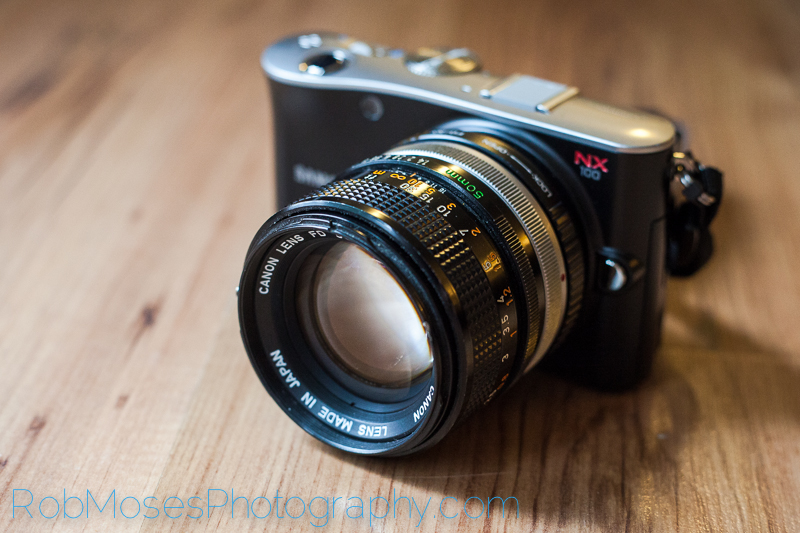What does the lettering on the lens indicate, and how can it help in photography? The lettering on the Canon FD lens provides crucial information about its specifications and functionality. For example, it may indicate the focal length (e.g., 50mm), maximum aperture (e.g., f/1.4), and other details such as lens series and filter size. This information helps photographers understand the lens's capabilities: the focal length determines the field of view, while the maximum aperture affects depth of field and low-light performance. Knowing these specifications allows photographers to choose the appropriate lens for their creative vision and technical needs, enabling them to achieve desired photographic effects and outcomes. Could you elaborate on how the maximum aperture impacts a photograph? The maximum aperture of a lens, indicated by the f-number (e.g., f/1.4), significantly impacts various aspects of a photograph. A larger maximum aperture (smaller f-number) allows more light to enter the lens, which enables better performance in low-light conditions, reducing the need for higher ISO settings that can introduce noise. It also provides a shallower depth of field, creating a pleasing background blur or bokeh effect, which is particularly desirable in portrait photography to isolate the subject from the background. Conversely, a smaller aperture (larger f-number) offers greater depth of field, ensuring more of the scene is in sharp focus, which is ideal for landscape photography. In a realistic scenario, how would a photographer make use of the shallow depth of field provided by an f/1.4 aperture? In a realistic scenario, a photographer might use a lens with an f/1.4 aperture during a portrait session to achieve a beautiful, creamy background blur that helps the subject stand out. By setting the aperture to f/1.4, the photographer can focus on the eyes of the subject, rendering them sharp and detailed, while the background elements melt away into a soft, aesthetically pleasing blur. This technique not only highlights the subject but also directs the viewer's attention to their facial expressions, creating a more intimate and impactful portrait. Describe a situation where a photographer would prefer using a smaller aperture, such as f/16, with this lens. A photographer might prefer using a smaller aperture, such as f/16, when capturing a landscape scene where maximum depth of field is desired. For instance, photographing a vast mountain range where the goal is to have both the foreground and the distant peaks in crisp focus would benefit from a smaller aperture setting. By setting the aperture to f/16, the photographer ensures that a larger portion of the image is in sharp focus, capturing intricate details throughout the scene. This technique is crucial for landscape photography, where the overall sharpness and clarity of the entire scene contribute to the visual impact and storytelling of the photograph. 